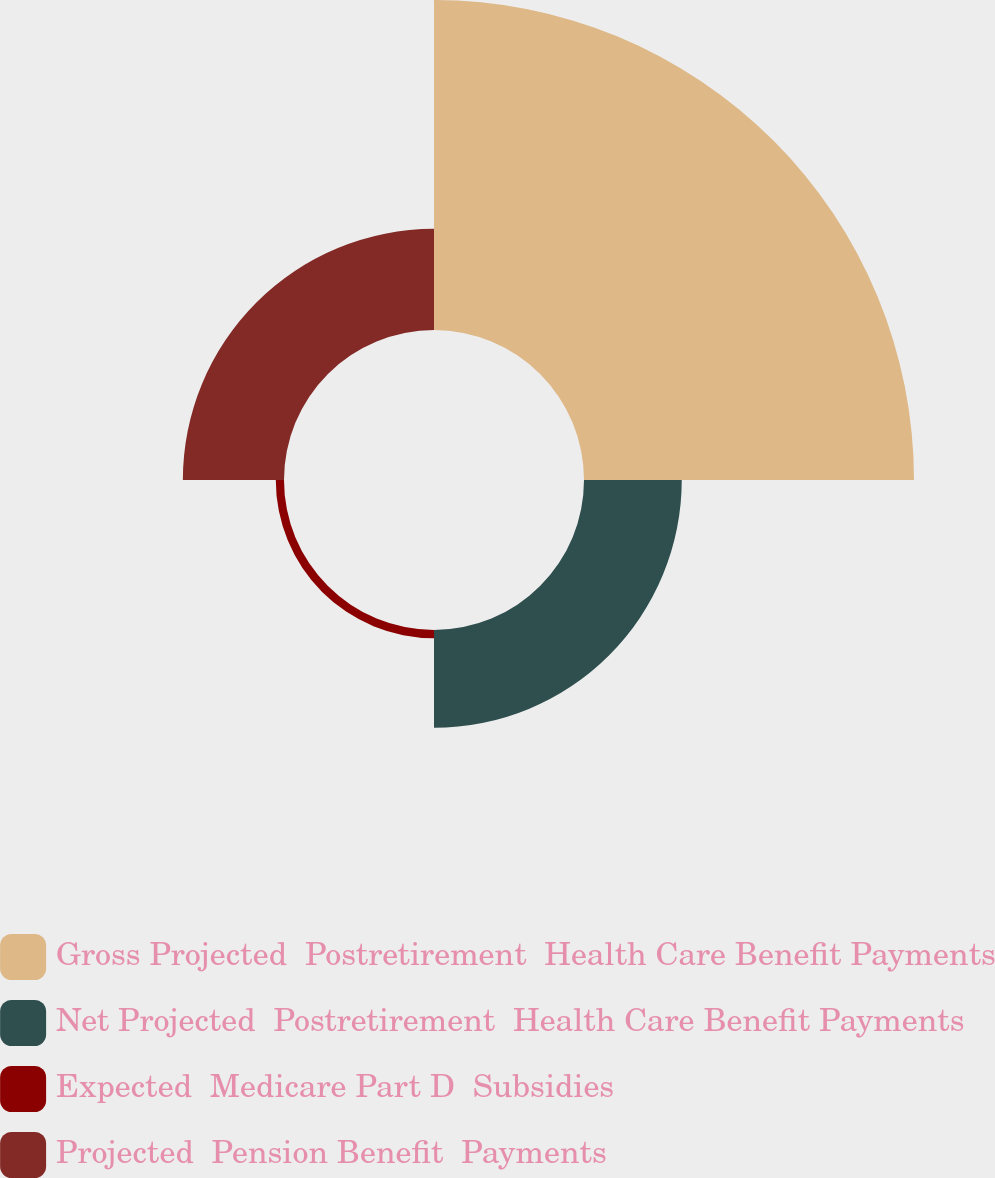Convert chart to OTSL. <chart><loc_0><loc_0><loc_500><loc_500><pie_chart><fcel>Gross Projected  Postretirement  Health Care Benefit Payments<fcel>Net Projected  Postretirement  Health Care Benefit Payments<fcel>Expected  Medicare Part D  Subsidies<fcel>Projected  Pension Benefit  Payments<nl><fcel>61.44%<fcel>18.2%<fcel>1.53%<fcel>18.83%<nl></chart> 